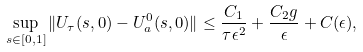<formula> <loc_0><loc_0><loc_500><loc_500>\sup _ { s \in [ 0 , 1 ] } \| U _ { \tau } ( s , 0 ) - U _ { a } ^ { 0 } ( s , 0 ) \| \leq \frac { C _ { 1 } } { \tau \epsilon ^ { 2 } } + \frac { C _ { 2 } g } { \epsilon } + C ( \epsilon ) ,</formula> 